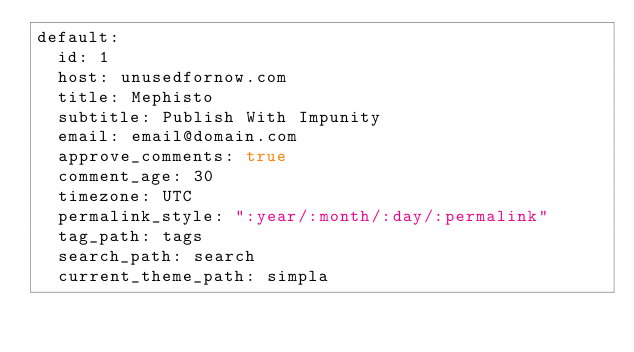Convert code to text. <code><loc_0><loc_0><loc_500><loc_500><_YAML_>default:
  id: 1
  host: unusedfornow.com
  title: Mephisto
  subtitle: Publish With Impunity
  email: email@domain.com
  approve_comments: true
  comment_age: 30
  timezone: UTC
  permalink_style: ":year/:month/:day/:permalink"
  tag_path: tags
  search_path: search
  current_theme_path: simpla</code> 